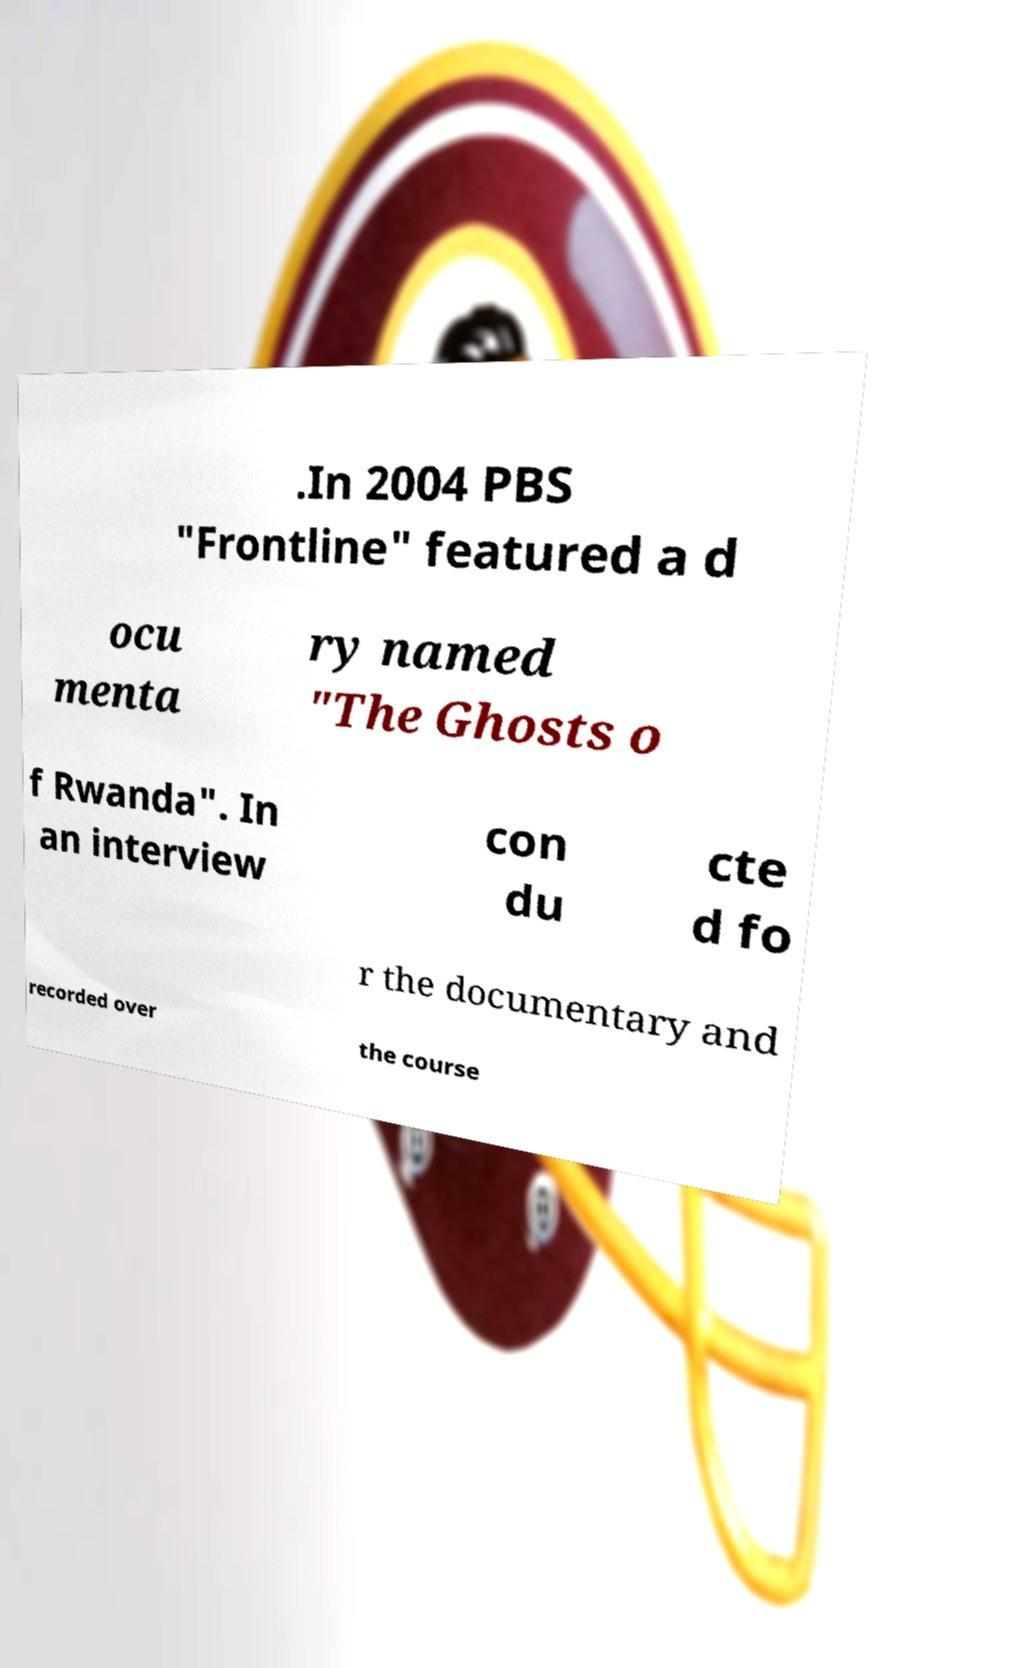Please read and relay the text visible in this image. What does it say? .In 2004 PBS "Frontline" featured a d ocu menta ry named "The Ghosts o f Rwanda". In an interview con du cte d fo r the documentary and recorded over the course 